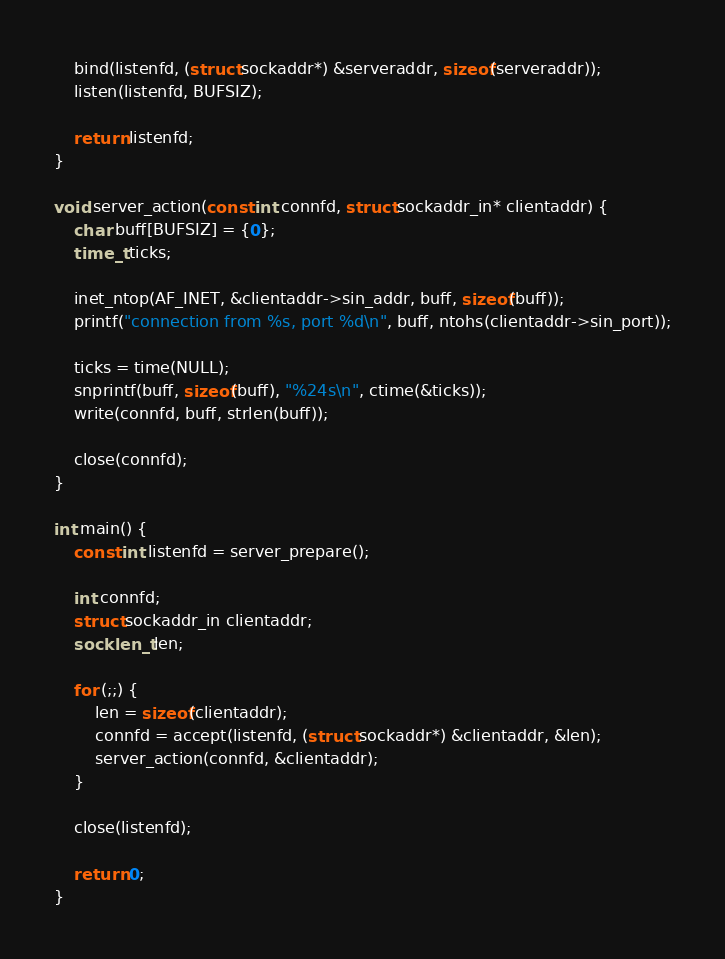Convert code to text. <code><loc_0><loc_0><loc_500><loc_500><_C_>    bind(listenfd, (struct sockaddr*) &serveraddr, sizeof(serveraddr));
    listen(listenfd, BUFSIZ);

    return listenfd;
}

void server_action(const int connfd, struct sockaddr_in* clientaddr) {
    char buff[BUFSIZ] = {0};
    time_t ticks;

    inet_ntop(AF_INET, &clientaddr->sin_addr, buff, sizeof(buff));
    printf("connection from %s, port %d\n", buff, ntohs(clientaddr->sin_port));

    ticks = time(NULL);
    snprintf(buff, sizeof(buff), "%24s\n", ctime(&ticks));
    write(connfd, buff, strlen(buff));

    close(connfd);
}

int main() {
    const int listenfd = server_prepare();

    int connfd;
    struct sockaddr_in clientaddr;
    socklen_t len;

    for (;;) {
        len = sizeof(clientaddr);
        connfd = accept(listenfd, (struct sockaddr*) &clientaddr, &len);
        server_action(connfd, &clientaddr);
    }

    close(listenfd);

    return 0;
}
</code> 